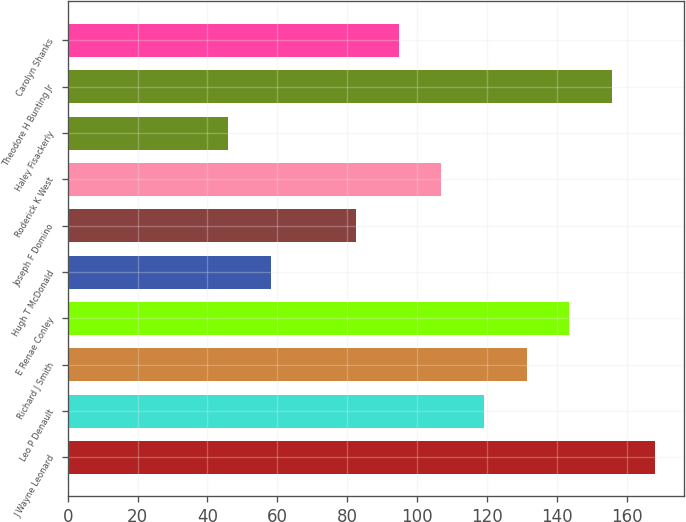Convert chart to OTSL. <chart><loc_0><loc_0><loc_500><loc_500><bar_chart><fcel>J Wayne Leonard<fcel>Leo P Denault<fcel>Richard J Smith<fcel>E Renae Conley<fcel>Hugh T McDonald<fcel>Joseph F Domino<fcel>Roderick K West<fcel>Haley Fisackerly<fcel>Theodore H Bunting Jr<fcel>Carolyn Shanks<nl><fcel>168<fcel>119.2<fcel>131.4<fcel>143.6<fcel>58.2<fcel>82.6<fcel>107<fcel>46<fcel>155.8<fcel>94.8<nl></chart> 